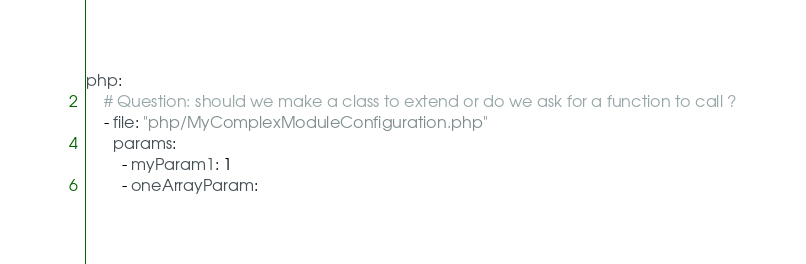Convert code to text. <code><loc_0><loc_0><loc_500><loc_500><_YAML_>php:
    # Question: should we make a class to extend or do we ask for a function to call ?
    - file: "php/MyComplexModuleConfiguration.php"
      params:
        - myParam1: 1
        - oneArrayParam:</code> 